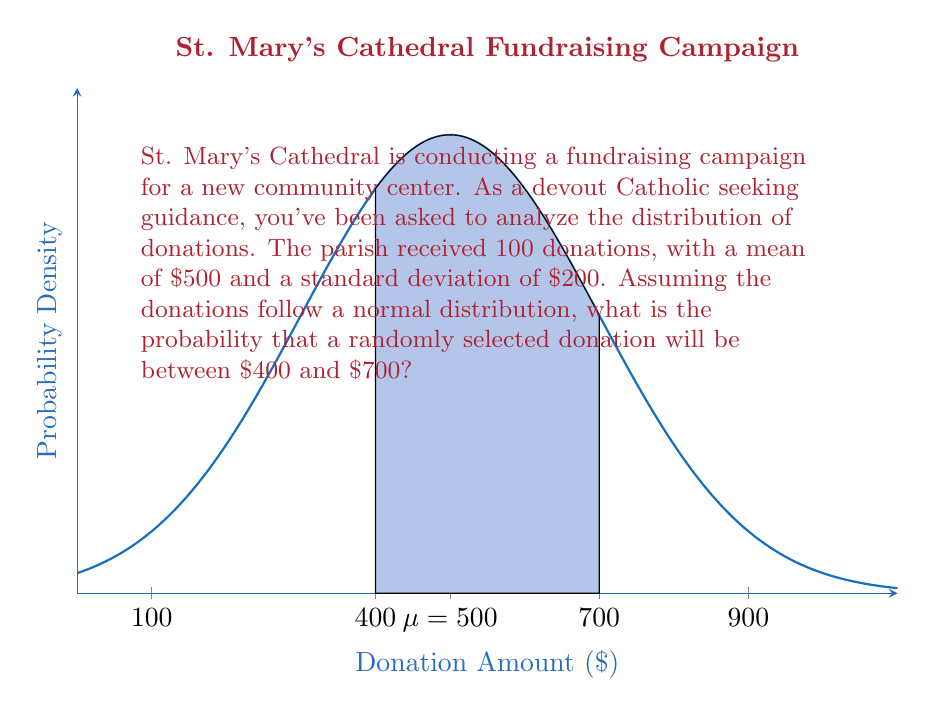Help me with this question. To solve this problem, we'll use the standard normal distribution and the z-score formula:

1) First, we need to calculate the z-scores for $400 and $700:

   $z = \frac{x - \mu}{\sigma}$

   For $400: z_1 = \frac{400 - 500}{200} = -0.5$
   For $700: z_2 = \frac{700 - 500}{200} = 1$

2) Now, we need to find the area under the standard normal curve between these two z-scores.

3) Using a standard normal table or calculator:
   $P(Z < -0.5) \approx 0.3085$
   $P(Z < 1) \approx 0.8413$

4) The probability we're looking for is the difference between these two values:

   $P(-0.5 < Z < 1) = P(Z < 1) - P(Z < -0.5)$
   $= 0.8413 - 0.3085 = 0.5328$

5) Therefore, the probability that a randomly selected donation will be between $400 and $700 is approximately 0.5328 or 53.28%.
Answer: 0.5328 or 53.28% 